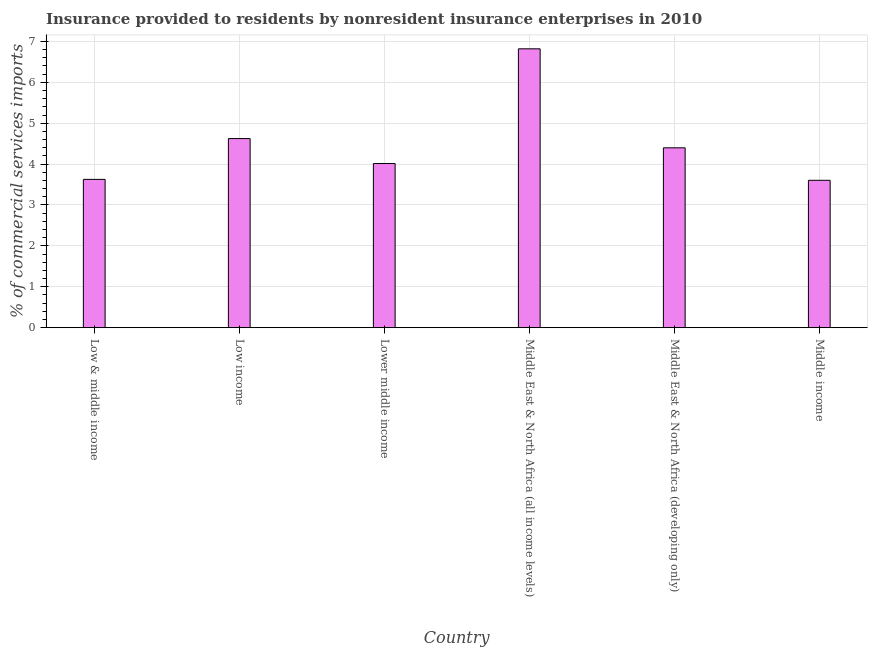Does the graph contain any zero values?
Keep it short and to the point. No. Does the graph contain grids?
Your answer should be very brief. Yes. What is the title of the graph?
Keep it short and to the point. Insurance provided to residents by nonresident insurance enterprises in 2010. What is the label or title of the X-axis?
Your answer should be very brief. Country. What is the label or title of the Y-axis?
Provide a short and direct response. % of commercial services imports. What is the insurance provided by non-residents in Lower middle income?
Your answer should be compact. 4.01. Across all countries, what is the maximum insurance provided by non-residents?
Provide a short and direct response. 6.82. Across all countries, what is the minimum insurance provided by non-residents?
Your answer should be compact. 3.6. In which country was the insurance provided by non-residents maximum?
Ensure brevity in your answer.  Middle East & North Africa (all income levels). What is the sum of the insurance provided by non-residents?
Your response must be concise. 27.09. What is the difference between the insurance provided by non-residents in Middle East & North Africa (all income levels) and Middle East & North Africa (developing only)?
Provide a short and direct response. 2.42. What is the average insurance provided by non-residents per country?
Ensure brevity in your answer.  4.51. What is the median insurance provided by non-residents?
Your answer should be very brief. 4.21. What is the ratio of the insurance provided by non-residents in Low & middle income to that in Middle income?
Ensure brevity in your answer.  1.01. Is the insurance provided by non-residents in Low & middle income less than that in Middle East & North Africa (developing only)?
Your answer should be very brief. Yes. Is the difference between the insurance provided by non-residents in Low & middle income and Low income greater than the difference between any two countries?
Offer a terse response. No. What is the difference between the highest and the second highest insurance provided by non-residents?
Ensure brevity in your answer.  2.19. Is the sum of the insurance provided by non-residents in Middle East & North Africa (all income levels) and Middle East & North Africa (developing only) greater than the maximum insurance provided by non-residents across all countries?
Provide a succinct answer. Yes. What is the difference between the highest and the lowest insurance provided by non-residents?
Make the answer very short. 3.22. What is the difference between two consecutive major ticks on the Y-axis?
Offer a terse response. 1. Are the values on the major ticks of Y-axis written in scientific E-notation?
Your answer should be compact. No. What is the % of commercial services imports of Low & middle income?
Give a very brief answer. 3.63. What is the % of commercial services imports of Low income?
Your response must be concise. 4.62. What is the % of commercial services imports of Lower middle income?
Offer a terse response. 4.01. What is the % of commercial services imports of Middle East & North Africa (all income levels)?
Your answer should be very brief. 6.82. What is the % of commercial services imports of Middle East & North Africa (developing only)?
Your answer should be very brief. 4.4. What is the % of commercial services imports in Middle income?
Offer a terse response. 3.6. What is the difference between the % of commercial services imports in Low & middle income and Low income?
Keep it short and to the point. -1. What is the difference between the % of commercial services imports in Low & middle income and Lower middle income?
Provide a succinct answer. -0.39. What is the difference between the % of commercial services imports in Low & middle income and Middle East & North Africa (all income levels)?
Offer a terse response. -3.19. What is the difference between the % of commercial services imports in Low & middle income and Middle East & North Africa (developing only)?
Your answer should be compact. -0.77. What is the difference between the % of commercial services imports in Low & middle income and Middle income?
Your answer should be very brief. 0.02. What is the difference between the % of commercial services imports in Low income and Lower middle income?
Your answer should be compact. 0.61. What is the difference between the % of commercial services imports in Low income and Middle East & North Africa (all income levels)?
Keep it short and to the point. -2.2. What is the difference between the % of commercial services imports in Low income and Middle East & North Africa (developing only)?
Ensure brevity in your answer.  0.23. What is the difference between the % of commercial services imports in Low income and Middle income?
Offer a very short reply. 1.02. What is the difference between the % of commercial services imports in Lower middle income and Middle East & North Africa (all income levels)?
Make the answer very short. -2.81. What is the difference between the % of commercial services imports in Lower middle income and Middle East & North Africa (developing only)?
Your answer should be very brief. -0.38. What is the difference between the % of commercial services imports in Lower middle income and Middle income?
Your response must be concise. 0.41. What is the difference between the % of commercial services imports in Middle East & North Africa (all income levels) and Middle East & North Africa (developing only)?
Give a very brief answer. 2.42. What is the difference between the % of commercial services imports in Middle East & North Africa (all income levels) and Middle income?
Your response must be concise. 3.22. What is the difference between the % of commercial services imports in Middle East & North Africa (developing only) and Middle income?
Provide a succinct answer. 0.79. What is the ratio of the % of commercial services imports in Low & middle income to that in Low income?
Offer a terse response. 0.78. What is the ratio of the % of commercial services imports in Low & middle income to that in Lower middle income?
Offer a very short reply. 0.9. What is the ratio of the % of commercial services imports in Low & middle income to that in Middle East & North Africa (all income levels)?
Your response must be concise. 0.53. What is the ratio of the % of commercial services imports in Low & middle income to that in Middle East & North Africa (developing only)?
Make the answer very short. 0.82. What is the ratio of the % of commercial services imports in Low income to that in Lower middle income?
Make the answer very short. 1.15. What is the ratio of the % of commercial services imports in Low income to that in Middle East & North Africa (all income levels)?
Your answer should be very brief. 0.68. What is the ratio of the % of commercial services imports in Low income to that in Middle East & North Africa (developing only)?
Give a very brief answer. 1.05. What is the ratio of the % of commercial services imports in Low income to that in Middle income?
Provide a succinct answer. 1.28. What is the ratio of the % of commercial services imports in Lower middle income to that in Middle East & North Africa (all income levels)?
Your response must be concise. 0.59. What is the ratio of the % of commercial services imports in Lower middle income to that in Middle income?
Provide a short and direct response. 1.11. What is the ratio of the % of commercial services imports in Middle East & North Africa (all income levels) to that in Middle East & North Africa (developing only)?
Offer a terse response. 1.55. What is the ratio of the % of commercial services imports in Middle East & North Africa (all income levels) to that in Middle income?
Your answer should be very brief. 1.89. What is the ratio of the % of commercial services imports in Middle East & North Africa (developing only) to that in Middle income?
Provide a short and direct response. 1.22. 